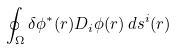Convert formula to latex. <formula><loc_0><loc_0><loc_500><loc_500>\oint _ { \Omega } \delta \phi ^ { * } ( r ) D _ { i } \phi ( r ) \, d s ^ { i } ( r )</formula> 